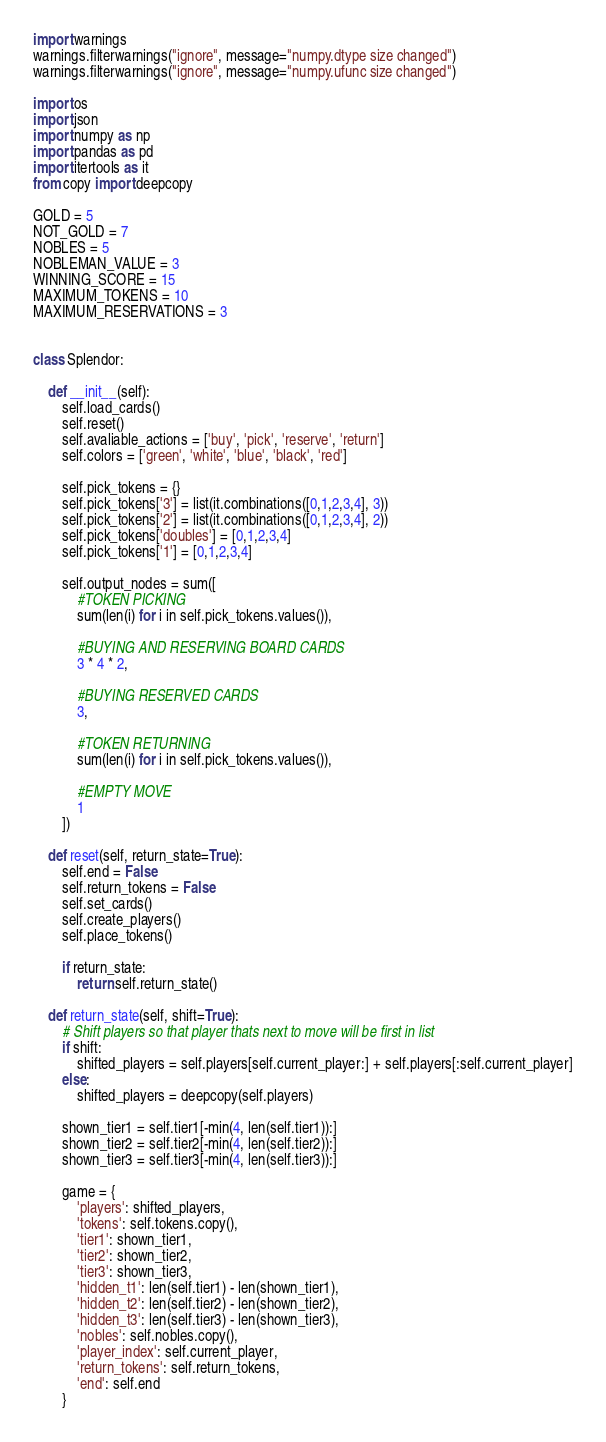<code> <loc_0><loc_0><loc_500><loc_500><_Python_>import warnings
warnings.filterwarnings("ignore", message="numpy.dtype size changed")
warnings.filterwarnings("ignore", message="numpy.ufunc size changed")

import os
import json
import numpy as np
import pandas as pd
import itertools as it
from copy import deepcopy

GOLD = 5
NOT_GOLD = 7
NOBLES = 5
NOBLEMAN_VALUE = 3
WINNING_SCORE = 15
MAXIMUM_TOKENS = 10
MAXIMUM_RESERVATIONS = 3


class Splendor:

	def __init__(self):
		self.load_cards()
		self.reset()
		self.avaliable_actions = ['buy', 'pick', 'reserve', 'return']
		self.colors = ['green', 'white', 'blue', 'black', 'red']

		self.pick_tokens = {}
		self.pick_tokens['3'] = list(it.combinations([0,1,2,3,4], 3))
		self.pick_tokens['2'] = list(it.combinations([0,1,2,3,4], 2))
		self.pick_tokens['doubles'] = [0,1,2,3,4]
		self.pick_tokens['1'] = [0,1,2,3,4]

		self.output_nodes = sum([
			#TOKEN PICKING
			sum(len(i) for i in self.pick_tokens.values()),

			#BUYING AND RESERVING BOARD CARDS
			3 * 4 * 2,

			#BUYING RESERVED CARDS
			3,

			#TOKEN RETURNING
			sum(len(i) for i in self.pick_tokens.values()),

			#EMPTY MOVE
			1
		])

	def reset(self, return_state=True):
		self.end = False
		self.return_tokens = False
		self.set_cards()
		self.create_players()
		self.place_tokens()
		
		if return_state:
			return self.return_state()

	def return_state(self, shift=True):
		# Shift players so that player thats next to move will be first in list
		if shift:
			shifted_players = self.players[self.current_player:] + self.players[:self.current_player]
		else:
			shifted_players = deepcopy(self.players)

		shown_tier1 = self.tier1[-min(4, len(self.tier1)):]
		shown_tier2 = self.tier2[-min(4, len(self.tier2)):]
		shown_tier3 = self.tier3[-min(4, len(self.tier3)):]

		game = {
			'players': shifted_players,
			'tokens': self.tokens.copy(),
			'tier1': shown_tier1,
			'tier2': shown_tier2,
			'tier3': shown_tier3,
			'hidden_t1': len(self.tier1) - len(shown_tier1),
			'hidden_t2': len(self.tier2) - len(shown_tier2),
			'hidden_t3': len(self.tier3) - len(shown_tier3),
			'nobles': self.nobles.copy(),
			'player_index': self.current_player,
			'return_tokens': self.return_tokens,
			'end': self.end
		}
</code> 